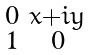Convert formula to latex. <formula><loc_0><loc_0><loc_500><loc_500>\begin{smallmatrix} 0 & x + i y \\ 1 & 0 \end{smallmatrix}</formula> 